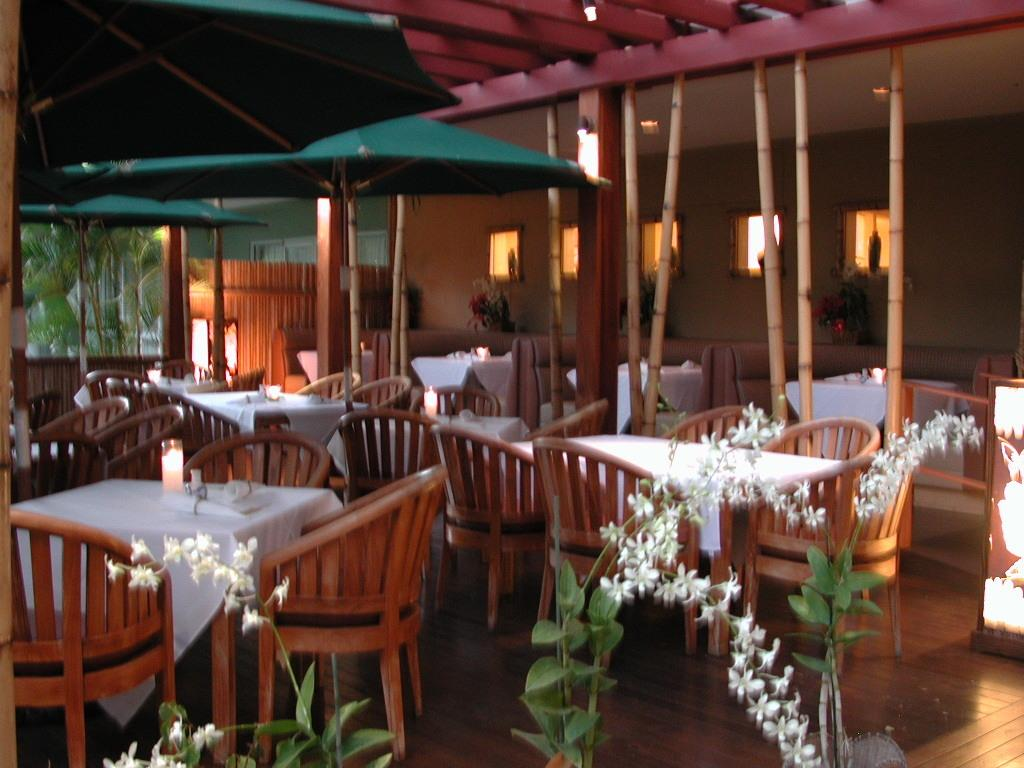What type of furniture is present in the image? There are tables and chairs in the image. What can be found at the bottom of the image? There are plants and flowers at the bottom of the image. What objects are visible in the background of the image? There are parasols and trees in the background of the image. What can be used for illumination in the image? There are lights visible in the image. What architectural feature is present in the image? There are windows visible in the image. How many rays are visible coming from the lights in the image? There is no mention of rays in the image; only lights are visible. What type of animals are present in the image? There are no animals, including horses, mentioned or visible in the image. What type of fruit is present in the image? There is no mention of fruit, including apples, in the image. 